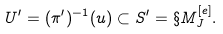<formula> <loc_0><loc_0><loc_500><loc_500>U ^ { \prime } = ( \pi ^ { \prime } ) ^ { - 1 } ( u ) \subset S ^ { \prime } = \S M ^ { [ e ] } _ { J } .</formula> 